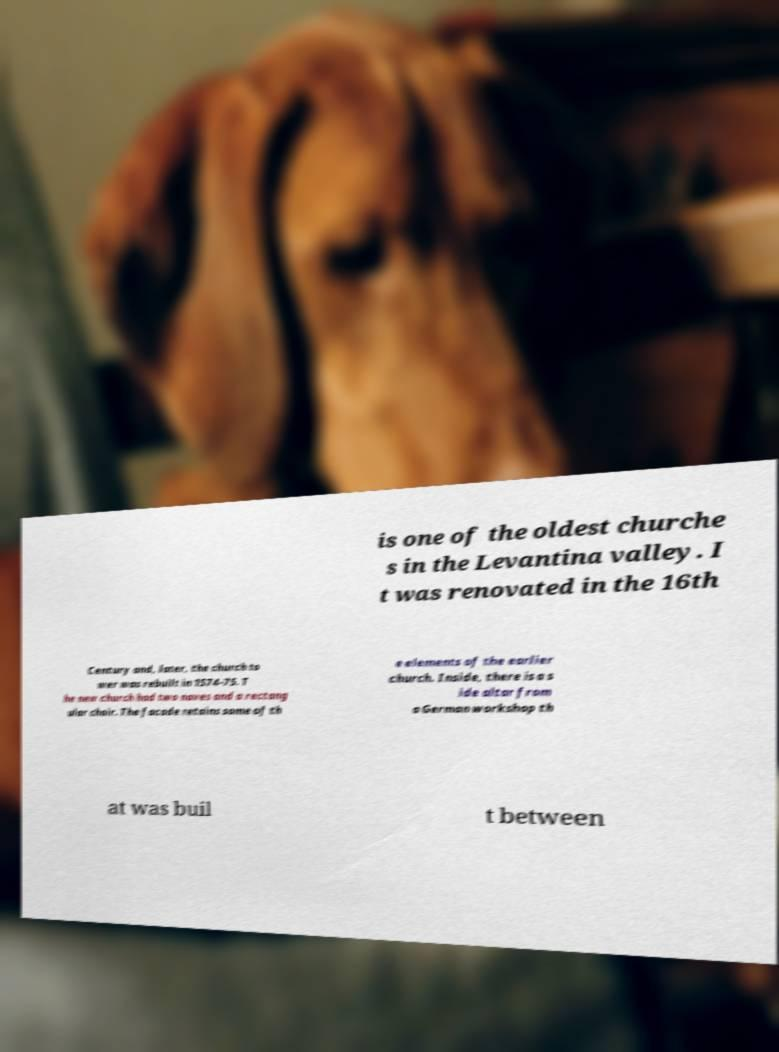Could you extract and type out the text from this image? is one of the oldest churche s in the Levantina valley. I t was renovated in the 16th Century and, later, the church to wer was rebuilt in 1574-75. T he new church had two naves and a rectang ular choir. The facade retains some of th e elements of the earlier church. Inside, there is a s ide altar from a German workshop th at was buil t between 